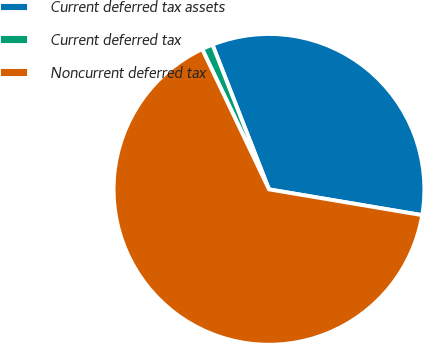Convert chart to OTSL. <chart><loc_0><loc_0><loc_500><loc_500><pie_chart><fcel>Current deferred tax assets<fcel>Current deferred tax<fcel>Noncurrent deferred tax<nl><fcel>33.58%<fcel>1.15%<fcel>65.27%<nl></chart> 